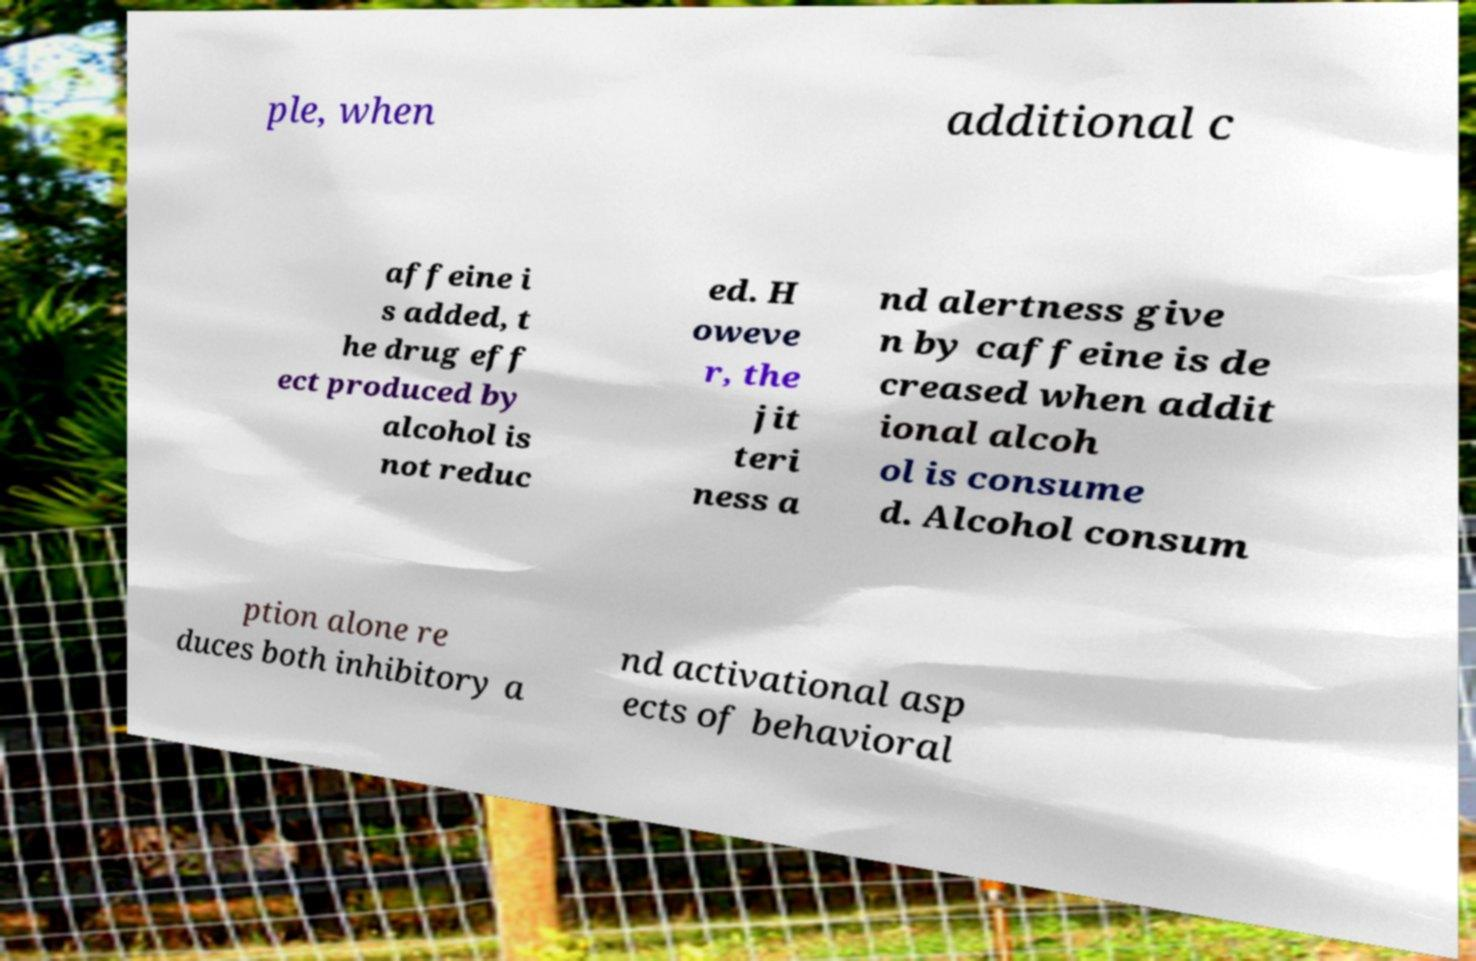Could you assist in decoding the text presented in this image and type it out clearly? ple, when additional c affeine i s added, t he drug eff ect produced by alcohol is not reduc ed. H oweve r, the jit teri ness a nd alertness give n by caffeine is de creased when addit ional alcoh ol is consume d. Alcohol consum ption alone re duces both inhibitory a nd activational asp ects of behavioral 